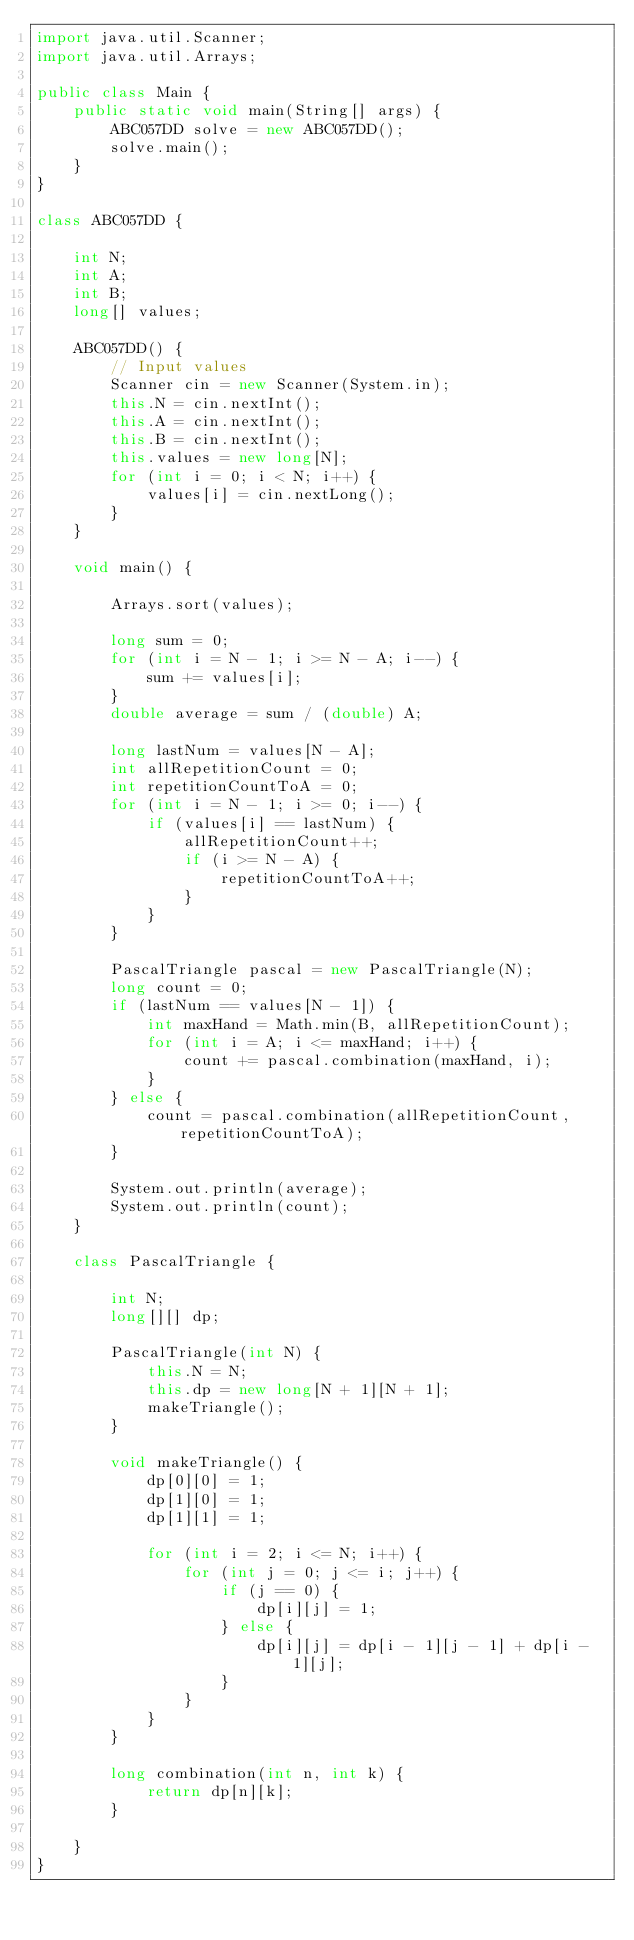<code> <loc_0><loc_0><loc_500><loc_500><_Java_>import java.util.Scanner;
import java.util.Arrays;

public class Main {
	public static void main(String[] args) {
		ABC057DD solve = new ABC057DD();
		solve.main();
	}
}

class ABC057DD {
	
	int N;
	int A;
	int B;
	long[] values;
	
	ABC057DD() {
		// Input values
		Scanner cin = new Scanner(System.in);
		this.N = cin.nextInt();
		this.A = cin.nextInt();
		this.B = cin.nextInt();
		this.values = new long[N];
		for (int i = 0; i < N; i++) {
			values[i] = cin.nextLong();
		}
	}
	
	void main() {
	
		Arrays.sort(values);
		
		long sum = 0;
		for (int i = N - 1; i >= N - A; i--) {
			sum += values[i];
		}
		double average = sum / (double) A;
		
		long lastNum = values[N - A];
		int allRepetitionCount = 0;
		int repetitionCountToA = 0;
		for (int i = N - 1; i >= 0; i--) {
			if (values[i] == lastNum) {
				allRepetitionCount++;
				if (i >= N - A) {
					repetitionCountToA++;
				}
			}
		}
		
		PascalTriangle pascal = new PascalTriangle(N);
		long count = 0;
		if (lastNum == values[N - 1]) {
			int maxHand = Math.min(B, allRepetitionCount);
			for (int i = A; i <= maxHand; i++) {
				count += pascal.combination(maxHand, i);
			}
		} else {
			count = pascal.combination(allRepetitionCount, repetitionCountToA);
		}
		
		System.out.println(average);
		System.out.println(count);
	}
	
	class PascalTriangle {
		
		int N;
		long[][] dp;
		
		PascalTriangle(int N) {
			this.N = N;
			this.dp = new long[N + 1][N + 1];
			makeTriangle();
		}
		
		void makeTriangle() {
			dp[0][0] = 1;
			dp[1][0] = 1;
			dp[1][1] = 1;
			
			for (int i = 2; i <= N; i++) {
				for (int j = 0; j <= i; j++) {
					if (j == 0) {
						dp[i][j] = 1;
					} else {
						dp[i][j] = dp[i - 1][j - 1] + dp[i - 1][j];
					}					
				}
			}
		}
		
		long combination(int n, int k) {
			return dp[n][k];
		}
		
	}
}</code> 